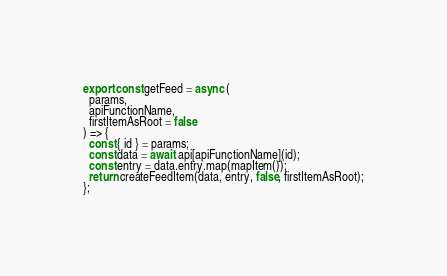<code> <loc_0><loc_0><loc_500><loc_500><_JavaScript_>
export const getFeed = async (
  params,
  apiFunctionName,
  firstItemAsRoot = false
) => {
  const { id } = params;
  const data = await api[apiFunctionName](id);
  const entry = data.entry.map(mapItem());
  return createFeedItem(data, entry, false, firstItemAsRoot);
};
</code> 